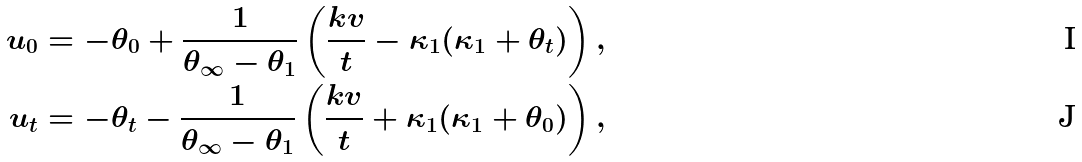Convert formula to latex. <formula><loc_0><loc_0><loc_500><loc_500>u _ { 0 } = - \theta _ { 0 } + \frac { 1 } { \theta _ { \infty } - \theta _ { 1 } } \left ( \frac { k v } { t } - \kappa _ { 1 } ( \kappa _ { 1 } + \theta _ { t } ) \right ) , \\ u _ { t } = - \theta _ { t } - \frac { 1 } { \theta _ { \infty } - \theta _ { 1 } } \left ( \frac { k v } { t } + \kappa _ { 1 } ( \kappa _ { 1 } + \theta _ { 0 } ) \right ) ,</formula> 